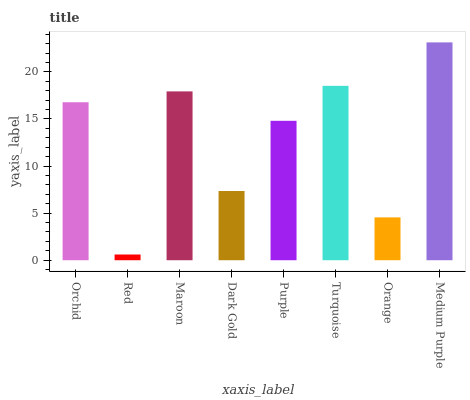Is Maroon the minimum?
Answer yes or no. No. Is Maroon the maximum?
Answer yes or no. No. Is Maroon greater than Red?
Answer yes or no. Yes. Is Red less than Maroon?
Answer yes or no. Yes. Is Red greater than Maroon?
Answer yes or no. No. Is Maroon less than Red?
Answer yes or no. No. Is Orchid the high median?
Answer yes or no. Yes. Is Purple the low median?
Answer yes or no. Yes. Is Purple the high median?
Answer yes or no. No. Is Dark Gold the low median?
Answer yes or no. No. 